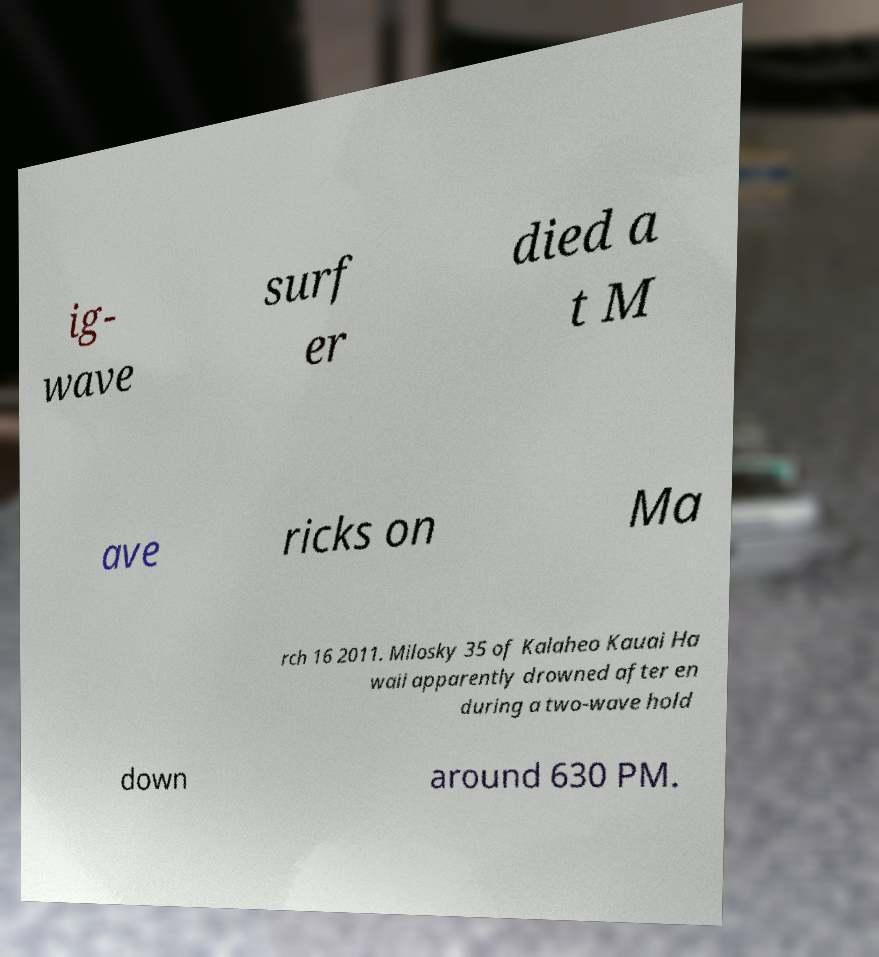Can you accurately transcribe the text from the provided image for me? ig- wave surf er died a t M ave ricks on Ma rch 16 2011. Milosky 35 of Kalaheo Kauai Ha waii apparently drowned after en during a two-wave hold down around 630 PM. 